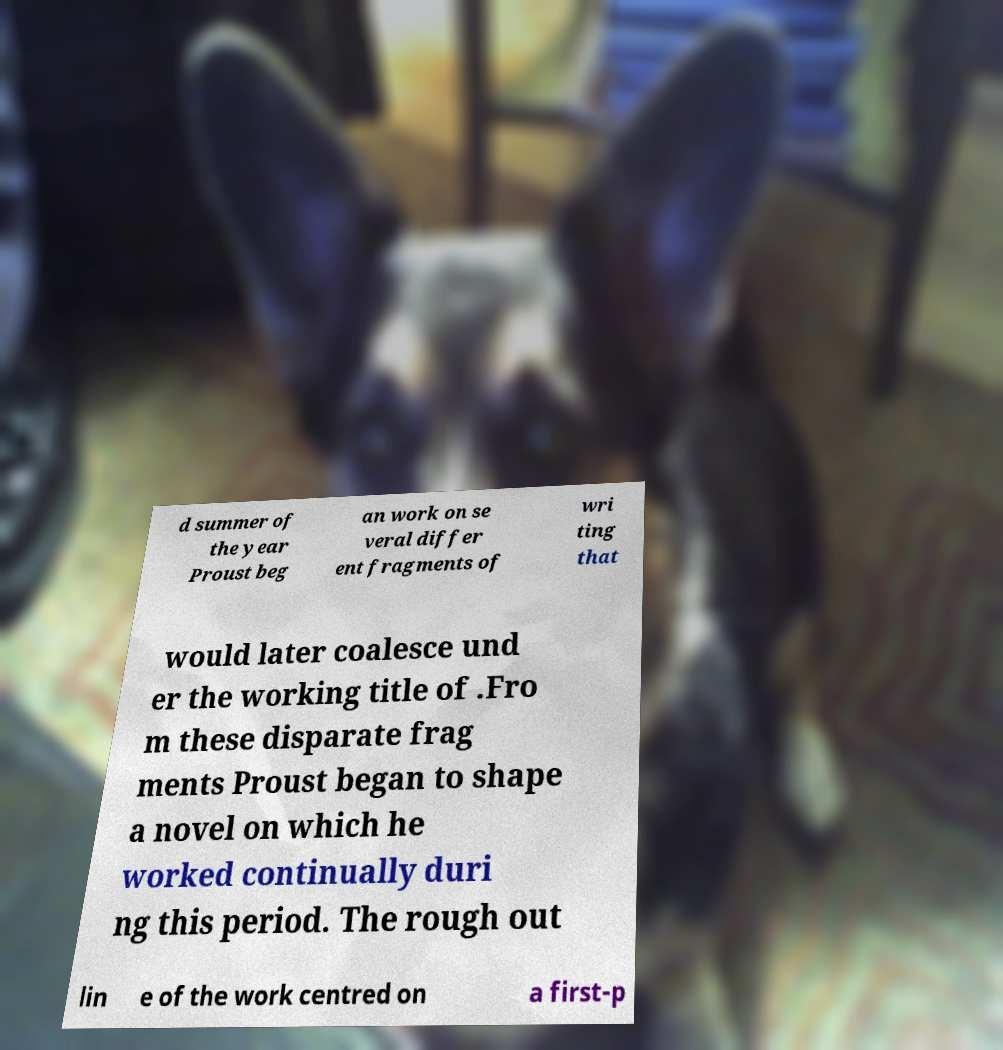Can you accurately transcribe the text from the provided image for me? d summer of the year Proust beg an work on se veral differ ent fragments of wri ting that would later coalesce und er the working title of .Fro m these disparate frag ments Proust began to shape a novel on which he worked continually duri ng this period. The rough out lin e of the work centred on a first-p 